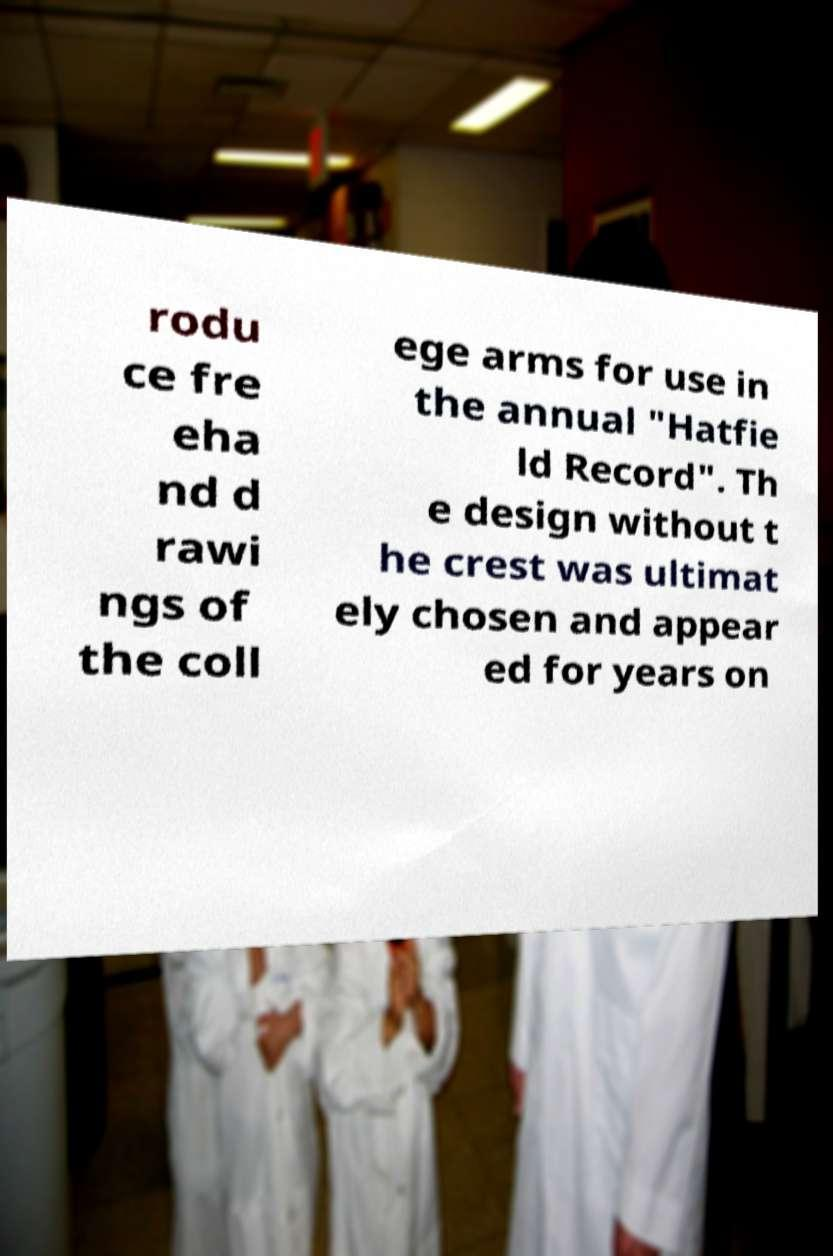For documentation purposes, I need the text within this image transcribed. Could you provide that? rodu ce fre eha nd d rawi ngs of the coll ege arms for use in the annual "Hatfie ld Record". Th e design without t he crest was ultimat ely chosen and appear ed for years on 